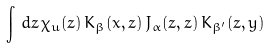Convert formula to latex. <formula><loc_0><loc_0><loc_500><loc_500>\int \, d z \, \chi _ { u } ( z ) \, K _ { \beta } ( x , z ) \, J _ { \alpha } ( z , z ) \, K _ { \beta ^ { \prime } } ( z , y )</formula> 